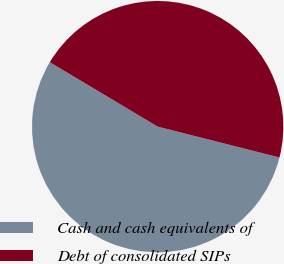Convert chart. <chart><loc_0><loc_0><loc_500><loc_500><pie_chart><fcel>Cash and cash equivalents of<fcel>Debt of consolidated SIPs<nl><fcel>54.62%<fcel>45.38%<nl></chart> 